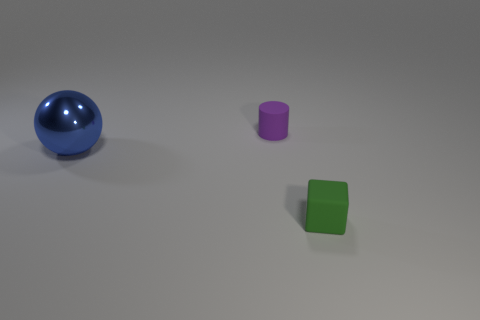Add 1 metallic spheres. How many objects exist? 4 Subtract all cubes. How many objects are left? 2 Subtract 0 cyan spheres. How many objects are left? 3 Subtract all red cylinders. Subtract all brown blocks. How many cylinders are left? 1 Subtract all blue balls. Subtract all blue metallic spheres. How many objects are left? 1 Add 1 big blue metal spheres. How many big blue metal spheres are left? 2 Add 1 small rubber things. How many small rubber things exist? 3 